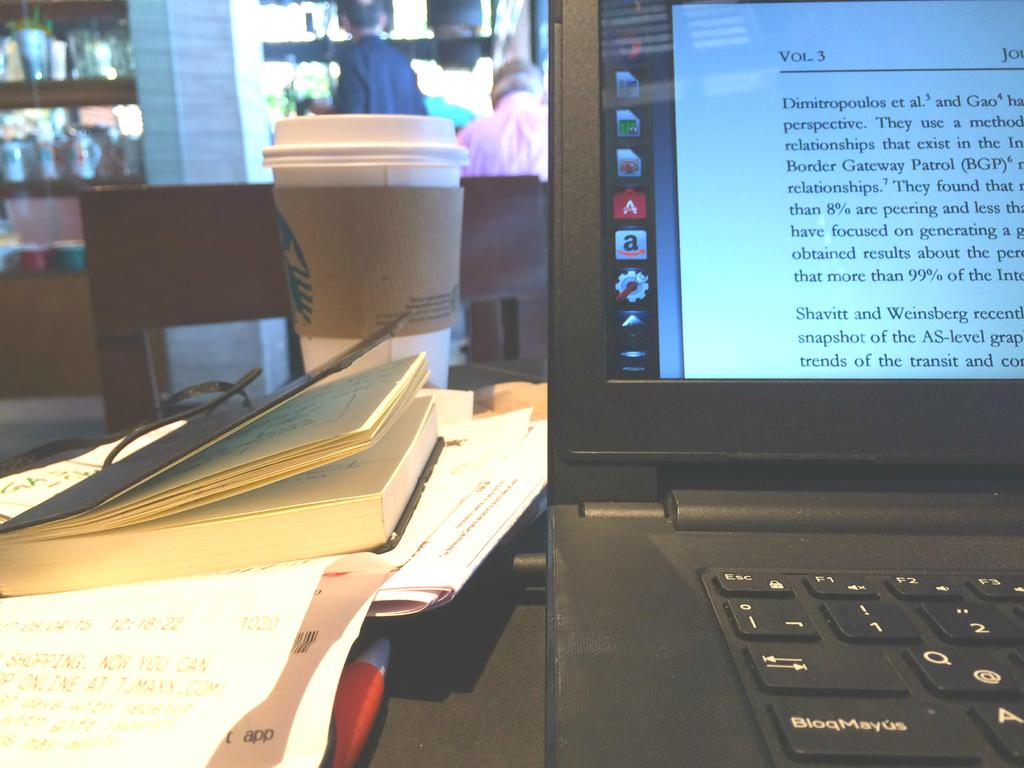<image>
Share a concise interpretation of the image provided. A laptop at a Starbucks displaying volume 3 on its screen. 